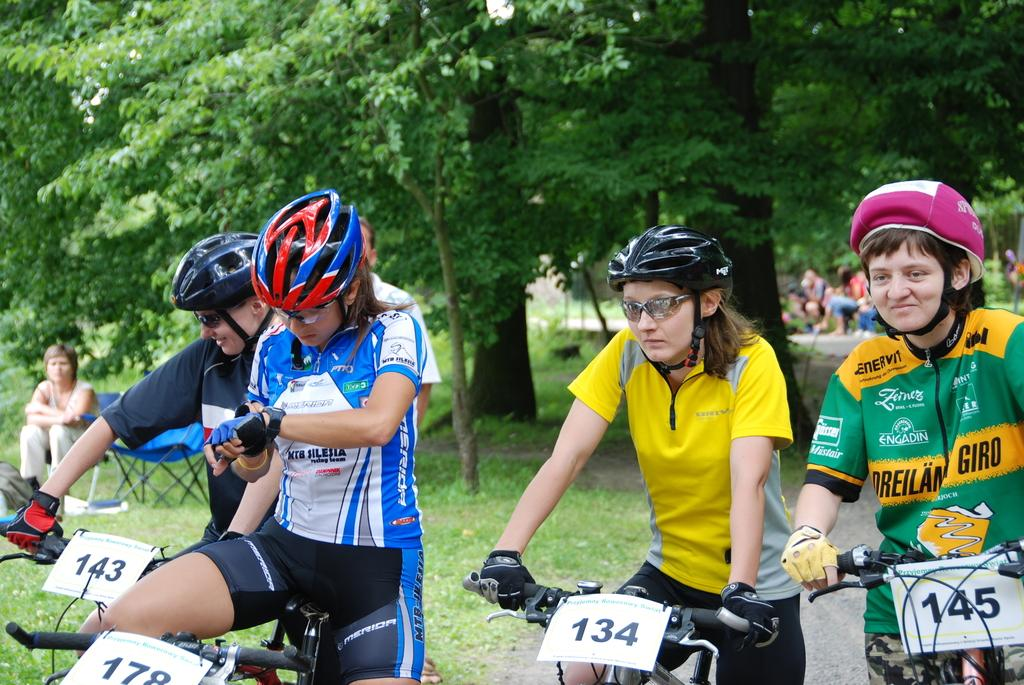What can be seen in the foreground of the image? In the foreground of the image, there are people, bicycles, grass, and a road. What is the terrain like in the foreground of the image? The terrain in the foreground of the image consists of grass. Can you describe the background of the image? In the background of the image, there are trees, chairs, more people, a road, plants, and grass. How many rocks can be seen in the image? There are no rocks present in the image. What type of crate is being used by the people in the background? There is no crate present in the image. What kind of flower is being held by the person in the foreground? There is no flower present in the image. 